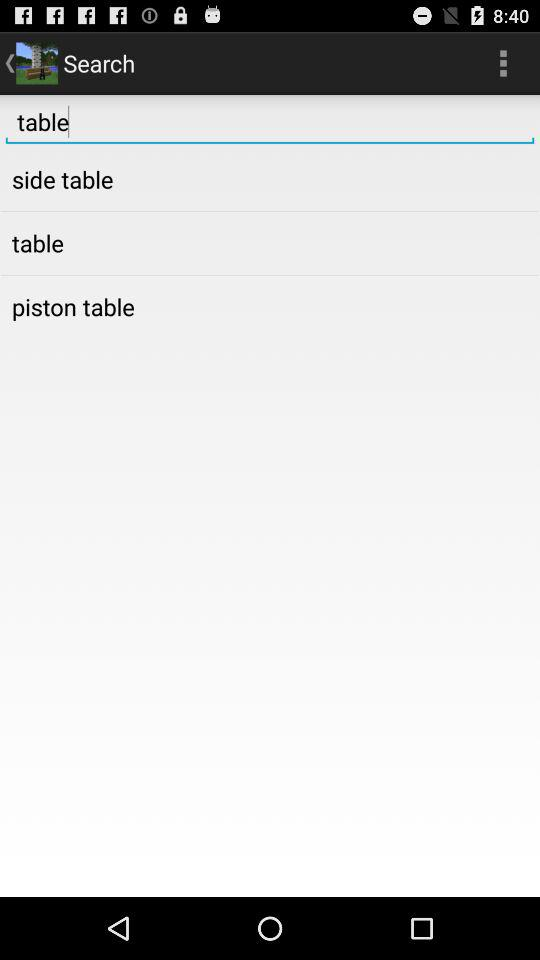How many results are there for the search "table"?
Answer the question using a single word or phrase. 3 